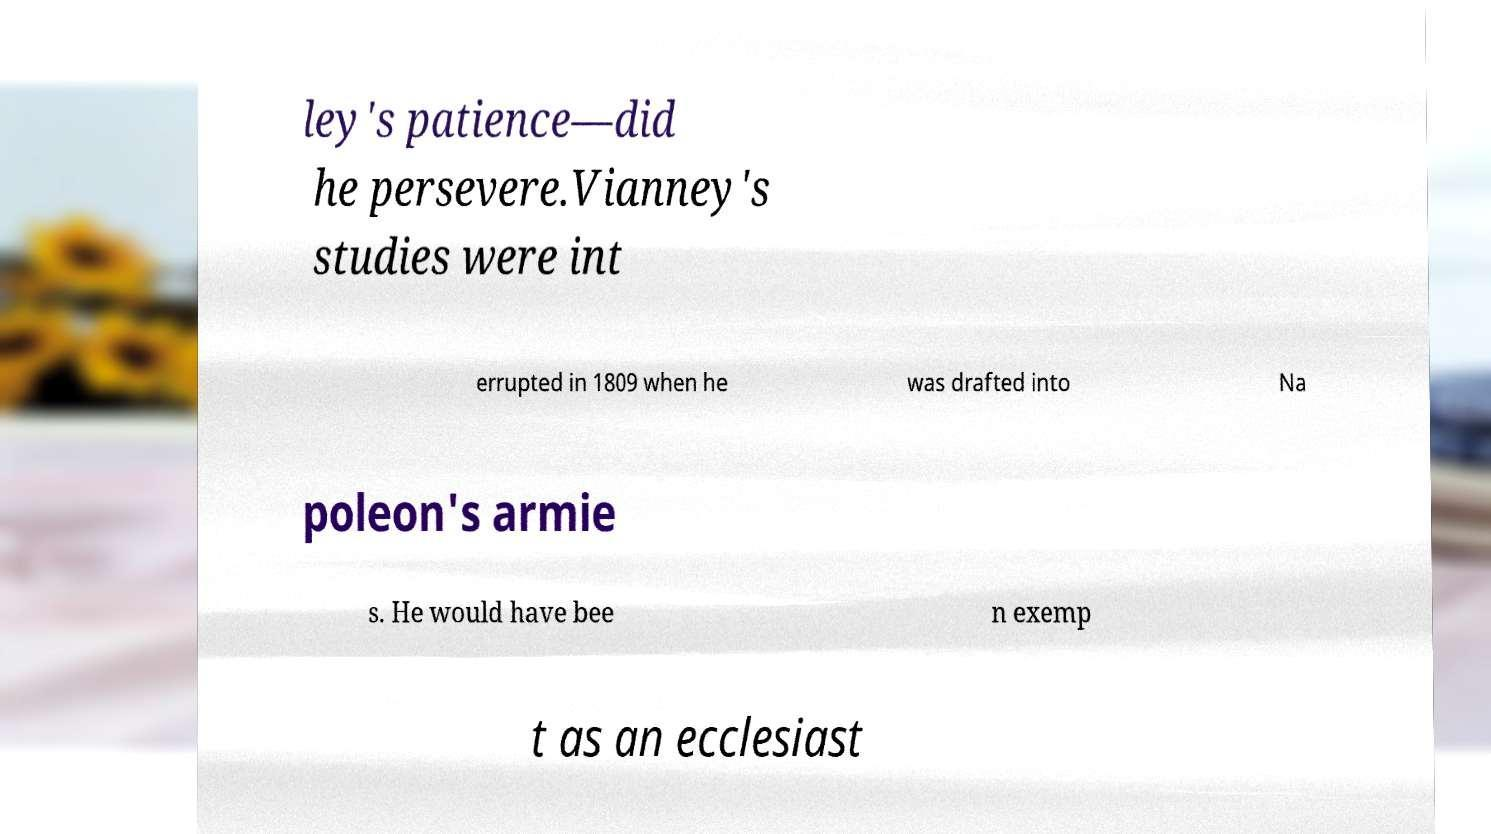I need the written content from this picture converted into text. Can you do that? ley's patience—did he persevere.Vianney's studies were int errupted in 1809 when he was drafted into Na poleon's armie s. He would have bee n exemp t as an ecclesiast 